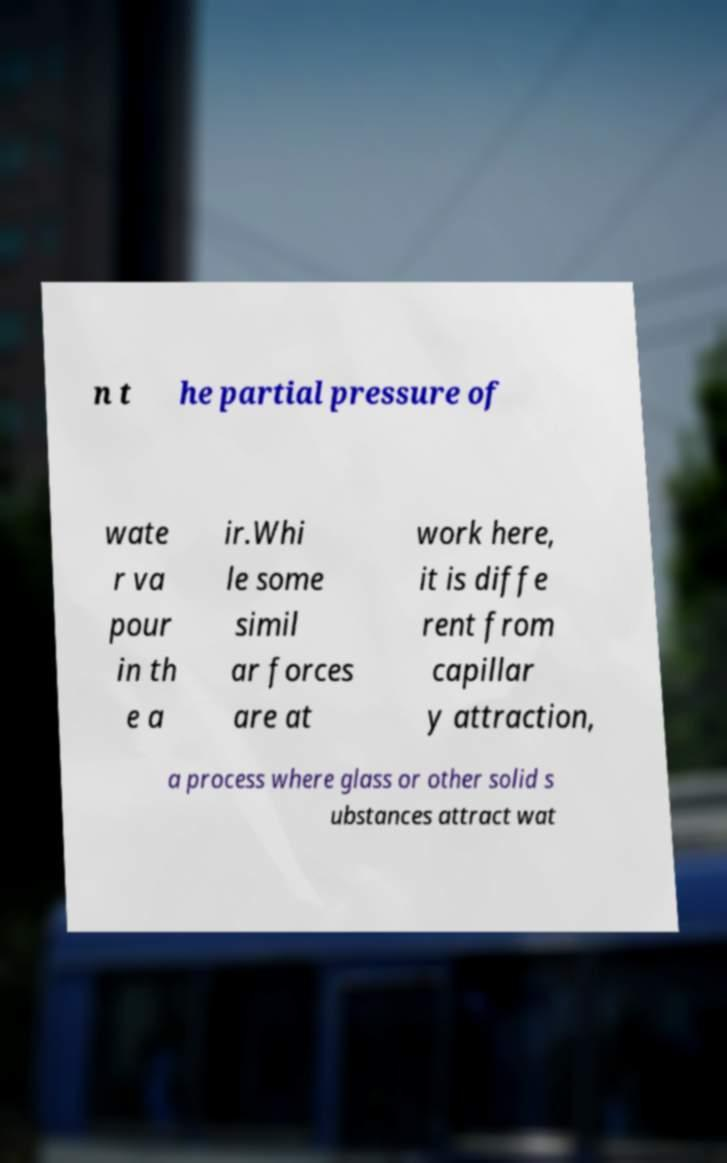There's text embedded in this image that I need extracted. Can you transcribe it verbatim? n t he partial pressure of wate r va pour in th e a ir.Whi le some simil ar forces are at work here, it is diffe rent from capillar y attraction, a process where glass or other solid s ubstances attract wat 